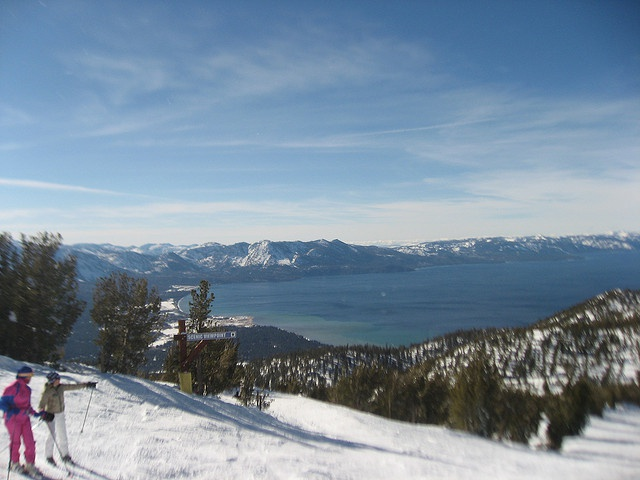Describe the objects in this image and their specific colors. I can see people in gray, darkgray, lightgray, and black tones, people in gray, purple, and navy tones, skis in gray, lightgray, and darkgray tones, and skis in gray, darkgray, and lightgray tones in this image. 